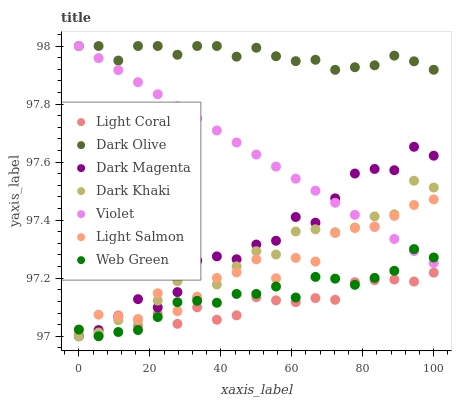Does Light Coral have the minimum area under the curve?
Answer yes or no. Yes. Does Dark Olive have the maximum area under the curve?
Answer yes or no. Yes. Does Light Salmon have the minimum area under the curve?
Answer yes or no. No. Does Light Salmon have the maximum area under the curve?
Answer yes or no. No. Is Violet the smoothest?
Answer yes or no. Yes. Is Light Salmon the roughest?
Answer yes or no. Yes. Is Dark Magenta the smoothest?
Answer yes or no. No. Is Dark Magenta the roughest?
Answer yes or no. No. Does Dark Khaki have the lowest value?
Answer yes or no. Yes. Does Light Salmon have the lowest value?
Answer yes or no. No. Does Violet have the highest value?
Answer yes or no. Yes. Does Light Salmon have the highest value?
Answer yes or no. No. Is Light Salmon less than Dark Olive?
Answer yes or no. Yes. Is Dark Olive greater than Light Salmon?
Answer yes or no. Yes. Does Violet intersect Dark Khaki?
Answer yes or no. Yes. Is Violet less than Dark Khaki?
Answer yes or no. No. Is Violet greater than Dark Khaki?
Answer yes or no. No. Does Light Salmon intersect Dark Olive?
Answer yes or no. No. 